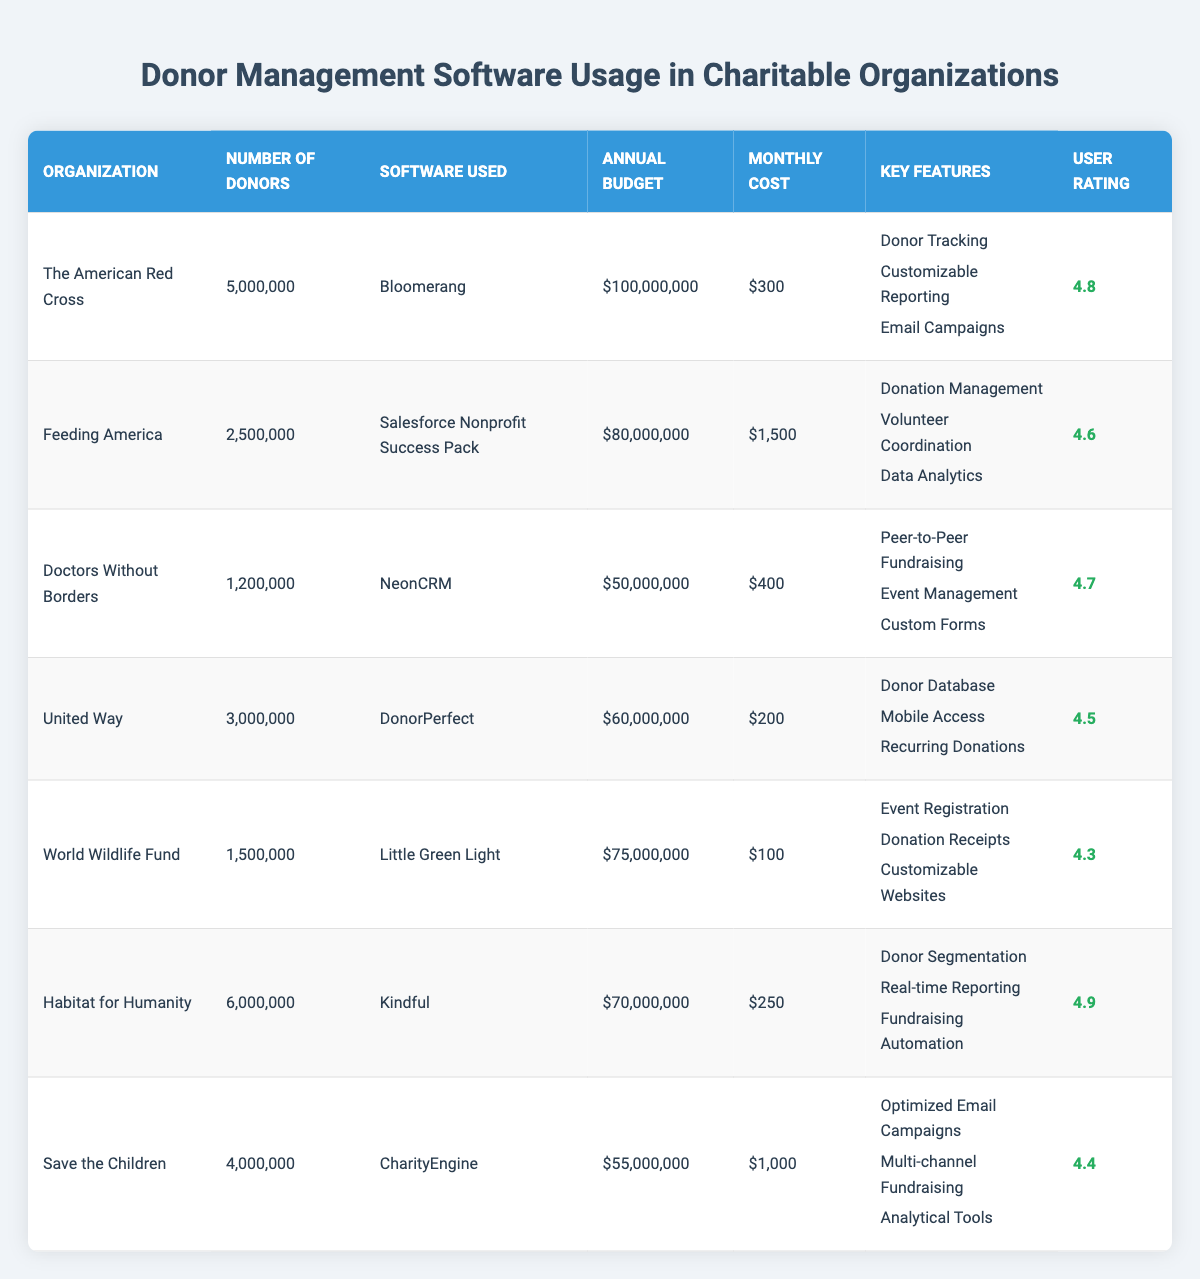What software is used by Habitat for Humanity? The table lists the software used by each organization, and for Habitat for Humanity, the software mentioned is Kindful.
Answer: Kindful What is the annual budget for Feeding America? The table provides the annual budget for each organization, and for Feeding America, it is $80,000,000.
Answer: $80,000,000 How many donors does World Wildlife Fund have? The table states that the number of donors for World Wildlife Fund is 1,500,000.
Answer: 1,500,000 Which organization has the highest user rating? Looking at the user ratings in the table, Habitat for Humanity has the highest rating of 4.9.
Answer: Habitat for Humanity What is the average monthly cost of the donor management software used by the organizations? The monthly costs for the organizations are $300, $1500, $400, $200, $100, $250, and $1000, which sums to $2750. Dividing by 7 gives an average of $392.86.
Answer: Approximately $392.86 Is the organization Doctors Without Borders using the software DonorPerfect? Checking the table, Doctors Without Borders is using NeonCRM, not DonorPerfect. Therefore, the answer is no.
Answer: No Which organization uses the most expensive software per month? By looking at the monthly costs, Feeding America has the highest cost at $1,500.
Answer: Feeding America How many more donors does Save the Children have compared to World Wildlife Fund? Save the Children has 4,000,000 donors and World Wildlife Fund has 1,500,000. The difference is 4,000,000 - 1,500,000 = 2,500,000.
Answer: 2,500,000 What is the total number of donors for The American Red Cross and Habitat for Humanity? The total can be calculated by adding the donors from both organizations: 5,000,000 (The American Red Cross) + 6,000,000 (Habitat for Humanity) = 11,000,000.
Answer: 11,000,000 Is it true that any organization has a monthly cost of less than $200? The table shows that United Way has a monthly cost of $200, and only World Wildlife Fund has a cost of $100, which confirms that it is true.
Answer: Yes Which three organizations have the highest number of donors? The organizations with the highest number of donors, according to the table, are The American Red Cross (5,000,000), Habitat for Humanity (6,000,000), and Save the Children (4,000,000). Summing these confirms they have the most donors.
Answer: Habitat for Humanity, The American Red Cross, Save the Children 